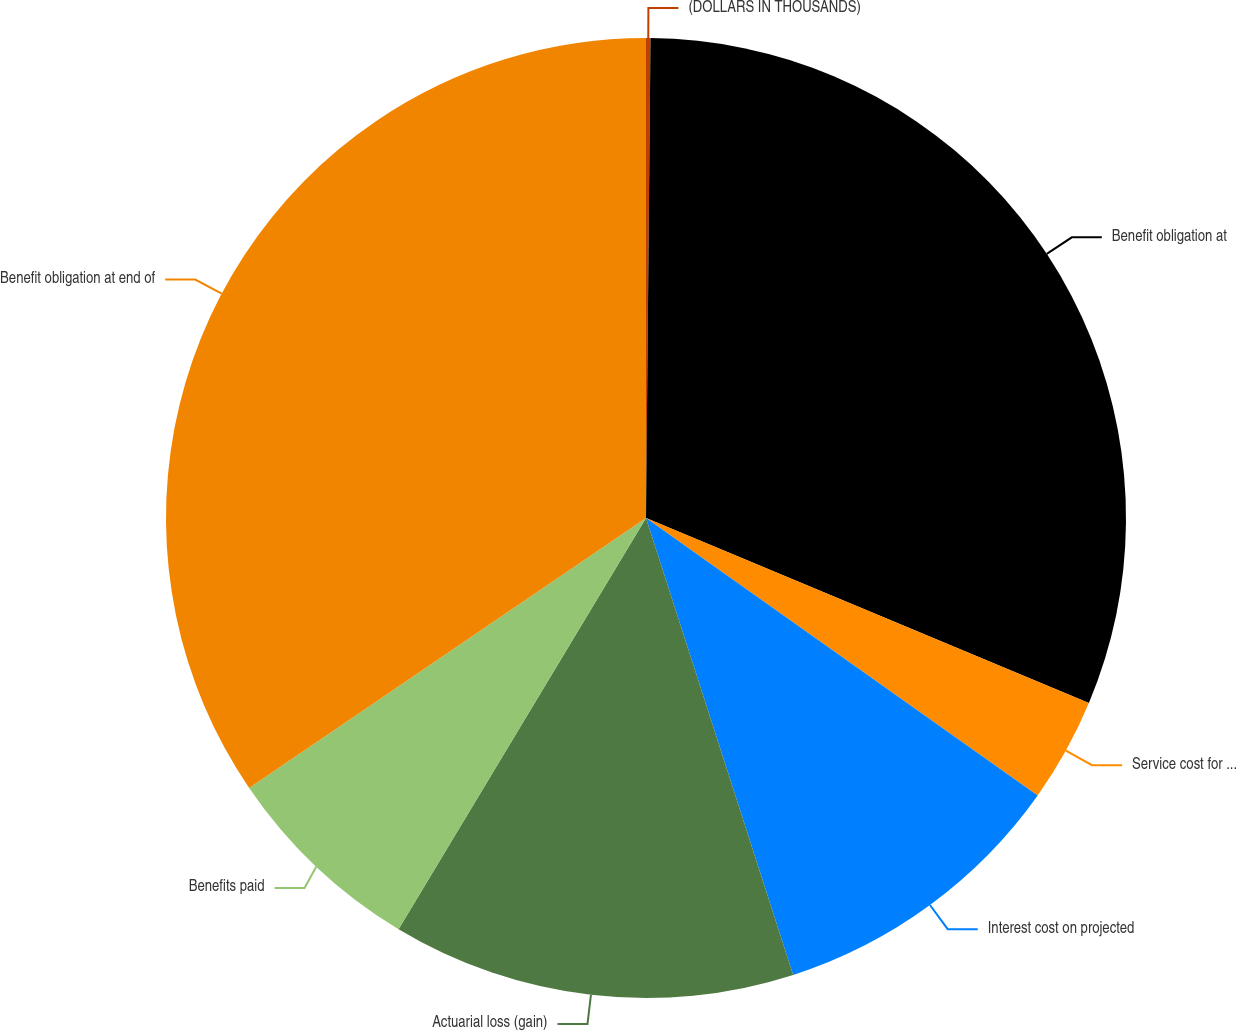Convert chart to OTSL. <chart><loc_0><loc_0><loc_500><loc_500><pie_chart><fcel>(DOLLARS IN THOUSANDS)<fcel>Benefit obligation at<fcel>Service cost for benefits<fcel>Interest cost on projected<fcel>Actuarial loss (gain)<fcel>Benefits paid<fcel>Benefit obligation at end of<nl><fcel>0.15%<fcel>31.15%<fcel>3.51%<fcel>10.23%<fcel>13.58%<fcel>6.87%<fcel>34.51%<nl></chart> 